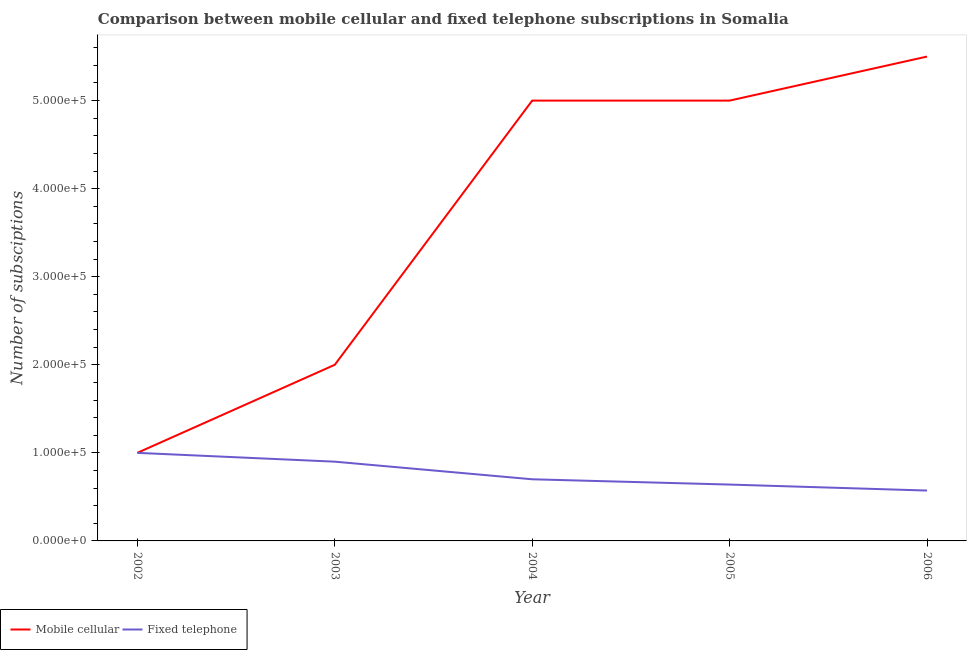How many different coloured lines are there?
Your answer should be very brief. 2. Does the line corresponding to number of mobile cellular subscriptions intersect with the line corresponding to number of fixed telephone subscriptions?
Provide a succinct answer. Yes. What is the number of mobile cellular subscriptions in 2002?
Keep it short and to the point. 1.00e+05. Across all years, what is the maximum number of fixed telephone subscriptions?
Give a very brief answer. 1.00e+05. Across all years, what is the minimum number of mobile cellular subscriptions?
Your answer should be very brief. 1.00e+05. In which year was the number of fixed telephone subscriptions minimum?
Provide a short and direct response. 2006. What is the total number of mobile cellular subscriptions in the graph?
Offer a terse response. 1.85e+06. What is the difference between the number of mobile cellular subscriptions in 2002 and that in 2006?
Keep it short and to the point. -4.50e+05. What is the difference between the number of mobile cellular subscriptions in 2003 and the number of fixed telephone subscriptions in 2005?
Offer a very short reply. 1.36e+05. What is the average number of mobile cellular subscriptions per year?
Provide a short and direct response. 3.70e+05. In the year 2005, what is the difference between the number of fixed telephone subscriptions and number of mobile cellular subscriptions?
Your response must be concise. -4.36e+05. What is the ratio of the number of fixed telephone subscriptions in 2005 to that in 2006?
Your response must be concise. 1.12. What is the difference between the highest and the lowest number of fixed telephone subscriptions?
Offer a terse response. 4.28e+04. Does the number of fixed telephone subscriptions monotonically increase over the years?
Make the answer very short. No. Is the number of fixed telephone subscriptions strictly less than the number of mobile cellular subscriptions over the years?
Give a very brief answer. No. How many years are there in the graph?
Ensure brevity in your answer.  5. Does the graph contain any zero values?
Keep it short and to the point. No. Where does the legend appear in the graph?
Your answer should be compact. Bottom left. How many legend labels are there?
Your answer should be compact. 2. What is the title of the graph?
Offer a very short reply. Comparison between mobile cellular and fixed telephone subscriptions in Somalia. Does "Rural" appear as one of the legend labels in the graph?
Ensure brevity in your answer.  No. What is the label or title of the Y-axis?
Provide a succinct answer. Number of subsciptions. What is the Number of subsciptions of Mobile cellular in 2003?
Offer a very short reply. 2.00e+05. What is the Number of subsciptions in Fixed telephone in 2004?
Your answer should be very brief. 7.00e+04. What is the Number of subsciptions in Fixed telephone in 2005?
Your answer should be compact. 6.40e+04. What is the Number of subsciptions of Mobile cellular in 2006?
Your response must be concise. 5.50e+05. What is the Number of subsciptions in Fixed telephone in 2006?
Ensure brevity in your answer.  5.72e+04. Across all years, what is the minimum Number of subsciptions in Mobile cellular?
Ensure brevity in your answer.  1.00e+05. Across all years, what is the minimum Number of subsciptions in Fixed telephone?
Make the answer very short. 5.72e+04. What is the total Number of subsciptions in Mobile cellular in the graph?
Give a very brief answer. 1.85e+06. What is the total Number of subsciptions in Fixed telephone in the graph?
Ensure brevity in your answer.  3.81e+05. What is the difference between the Number of subsciptions of Mobile cellular in 2002 and that in 2004?
Offer a terse response. -4.00e+05. What is the difference between the Number of subsciptions of Mobile cellular in 2002 and that in 2005?
Your response must be concise. -4.00e+05. What is the difference between the Number of subsciptions of Fixed telephone in 2002 and that in 2005?
Provide a short and direct response. 3.60e+04. What is the difference between the Number of subsciptions in Mobile cellular in 2002 and that in 2006?
Give a very brief answer. -4.50e+05. What is the difference between the Number of subsciptions in Fixed telephone in 2002 and that in 2006?
Offer a terse response. 4.28e+04. What is the difference between the Number of subsciptions of Mobile cellular in 2003 and that in 2004?
Your answer should be compact. -3.00e+05. What is the difference between the Number of subsciptions in Mobile cellular in 2003 and that in 2005?
Provide a short and direct response. -3.00e+05. What is the difference between the Number of subsciptions of Fixed telephone in 2003 and that in 2005?
Your answer should be compact. 2.60e+04. What is the difference between the Number of subsciptions in Mobile cellular in 2003 and that in 2006?
Give a very brief answer. -3.50e+05. What is the difference between the Number of subsciptions in Fixed telephone in 2003 and that in 2006?
Your answer should be very brief. 3.28e+04. What is the difference between the Number of subsciptions in Mobile cellular in 2004 and that in 2005?
Offer a very short reply. 0. What is the difference between the Number of subsciptions of Fixed telephone in 2004 and that in 2005?
Give a very brief answer. 6000. What is the difference between the Number of subsciptions in Fixed telephone in 2004 and that in 2006?
Your response must be concise. 1.28e+04. What is the difference between the Number of subsciptions of Fixed telephone in 2005 and that in 2006?
Give a very brief answer. 6800. What is the difference between the Number of subsciptions of Mobile cellular in 2002 and the Number of subsciptions of Fixed telephone in 2003?
Ensure brevity in your answer.  10000. What is the difference between the Number of subsciptions of Mobile cellular in 2002 and the Number of subsciptions of Fixed telephone in 2004?
Offer a very short reply. 3.00e+04. What is the difference between the Number of subsciptions of Mobile cellular in 2002 and the Number of subsciptions of Fixed telephone in 2005?
Your answer should be compact. 3.60e+04. What is the difference between the Number of subsciptions in Mobile cellular in 2002 and the Number of subsciptions in Fixed telephone in 2006?
Offer a very short reply. 4.28e+04. What is the difference between the Number of subsciptions of Mobile cellular in 2003 and the Number of subsciptions of Fixed telephone in 2005?
Your answer should be very brief. 1.36e+05. What is the difference between the Number of subsciptions in Mobile cellular in 2003 and the Number of subsciptions in Fixed telephone in 2006?
Offer a terse response. 1.43e+05. What is the difference between the Number of subsciptions of Mobile cellular in 2004 and the Number of subsciptions of Fixed telephone in 2005?
Give a very brief answer. 4.36e+05. What is the difference between the Number of subsciptions in Mobile cellular in 2004 and the Number of subsciptions in Fixed telephone in 2006?
Provide a succinct answer. 4.43e+05. What is the difference between the Number of subsciptions of Mobile cellular in 2005 and the Number of subsciptions of Fixed telephone in 2006?
Ensure brevity in your answer.  4.43e+05. What is the average Number of subsciptions in Mobile cellular per year?
Your answer should be very brief. 3.70e+05. What is the average Number of subsciptions of Fixed telephone per year?
Ensure brevity in your answer.  7.62e+04. In the year 2003, what is the difference between the Number of subsciptions in Mobile cellular and Number of subsciptions in Fixed telephone?
Your response must be concise. 1.10e+05. In the year 2005, what is the difference between the Number of subsciptions in Mobile cellular and Number of subsciptions in Fixed telephone?
Provide a short and direct response. 4.36e+05. In the year 2006, what is the difference between the Number of subsciptions of Mobile cellular and Number of subsciptions of Fixed telephone?
Your answer should be compact. 4.93e+05. What is the ratio of the Number of subsciptions of Mobile cellular in 2002 to that in 2003?
Your answer should be very brief. 0.5. What is the ratio of the Number of subsciptions of Mobile cellular in 2002 to that in 2004?
Offer a terse response. 0.2. What is the ratio of the Number of subsciptions in Fixed telephone in 2002 to that in 2004?
Your answer should be compact. 1.43. What is the ratio of the Number of subsciptions in Fixed telephone in 2002 to that in 2005?
Give a very brief answer. 1.56. What is the ratio of the Number of subsciptions in Mobile cellular in 2002 to that in 2006?
Make the answer very short. 0.18. What is the ratio of the Number of subsciptions of Fixed telephone in 2002 to that in 2006?
Give a very brief answer. 1.75. What is the ratio of the Number of subsciptions in Mobile cellular in 2003 to that in 2004?
Your answer should be compact. 0.4. What is the ratio of the Number of subsciptions of Fixed telephone in 2003 to that in 2004?
Ensure brevity in your answer.  1.29. What is the ratio of the Number of subsciptions in Mobile cellular in 2003 to that in 2005?
Provide a short and direct response. 0.4. What is the ratio of the Number of subsciptions of Fixed telephone in 2003 to that in 2005?
Your response must be concise. 1.41. What is the ratio of the Number of subsciptions of Mobile cellular in 2003 to that in 2006?
Keep it short and to the point. 0.36. What is the ratio of the Number of subsciptions in Fixed telephone in 2003 to that in 2006?
Ensure brevity in your answer.  1.57. What is the ratio of the Number of subsciptions in Fixed telephone in 2004 to that in 2005?
Your answer should be compact. 1.09. What is the ratio of the Number of subsciptions of Mobile cellular in 2004 to that in 2006?
Ensure brevity in your answer.  0.91. What is the ratio of the Number of subsciptions in Fixed telephone in 2004 to that in 2006?
Offer a terse response. 1.22. What is the ratio of the Number of subsciptions of Mobile cellular in 2005 to that in 2006?
Provide a short and direct response. 0.91. What is the ratio of the Number of subsciptions in Fixed telephone in 2005 to that in 2006?
Provide a succinct answer. 1.12. What is the difference between the highest and the second highest Number of subsciptions in Mobile cellular?
Give a very brief answer. 5.00e+04. What is the difference between the highest and the lowest Number of subsciptions in Mobile cellular?
Provide a succinct answer. 4.50e+05. What is the difference between the highest and the lowest Number of subsciptions of Fixed telephone?
Keep it short and to the point. 4.28e+04. 